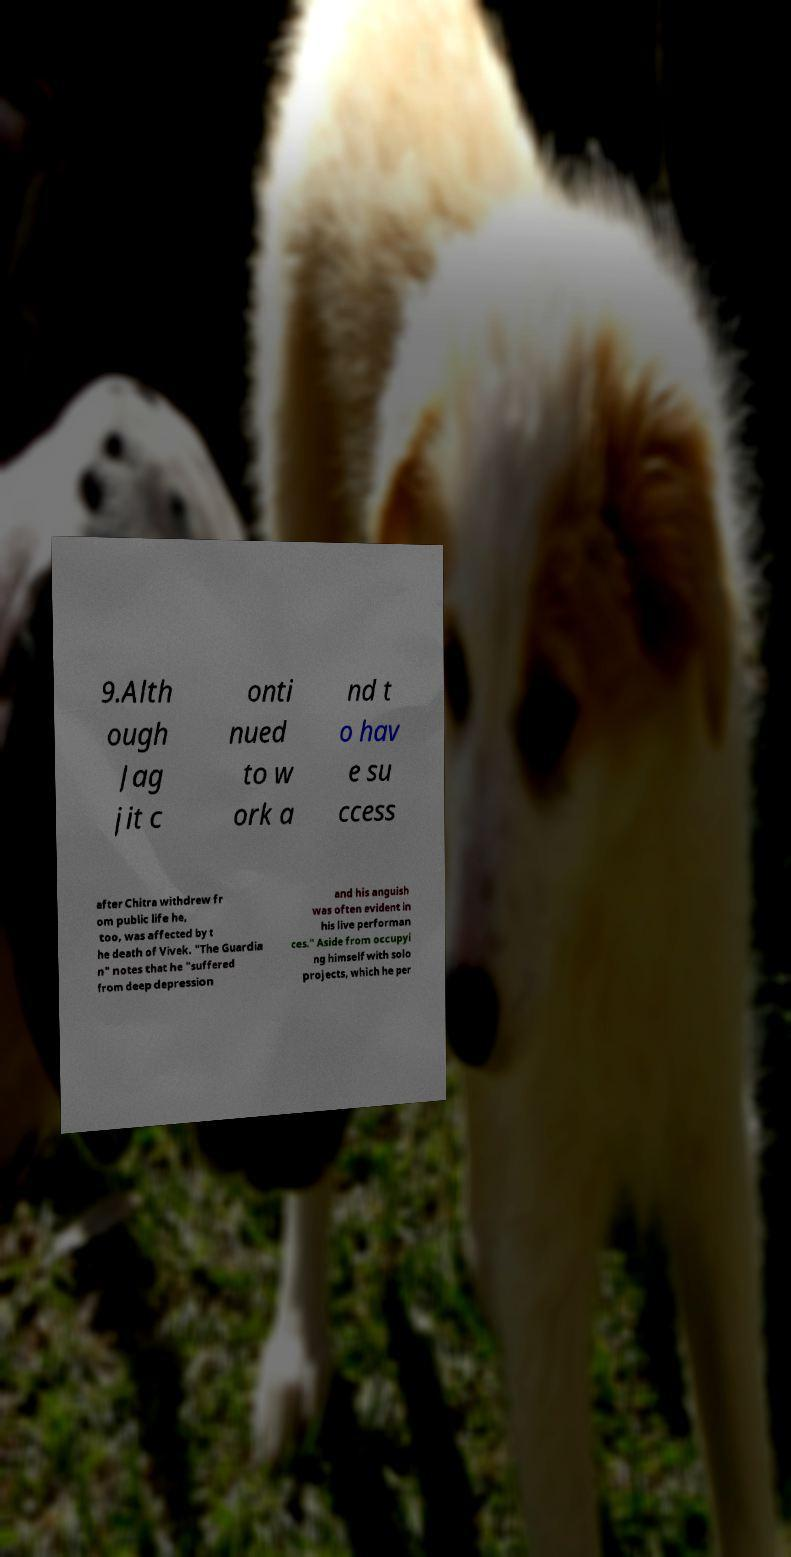Could you extract and type out the text from this image? 9.Alth ough Jag jit c onti nued to w ork a nd t o hav e su ccess after Chitra withdrew fr om public life he, too, was affected by t he death of Vivek. "The Guardia n" notes that he "suffered from deep depression and his anguish was often evident in his live performan ces." Aside from occupyi ng himself with solo projects, which he per 